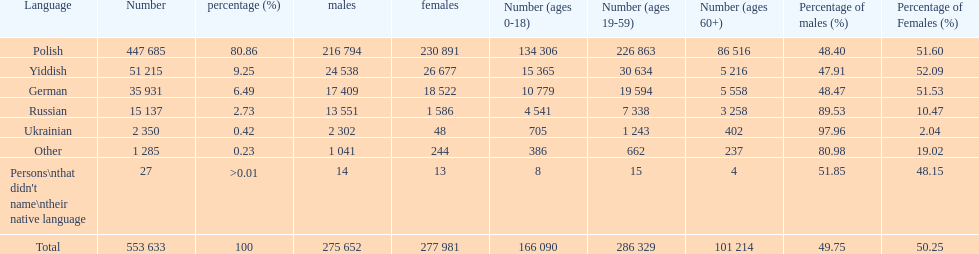How many speakers (of any language) are represented on the table ? 553 633. 